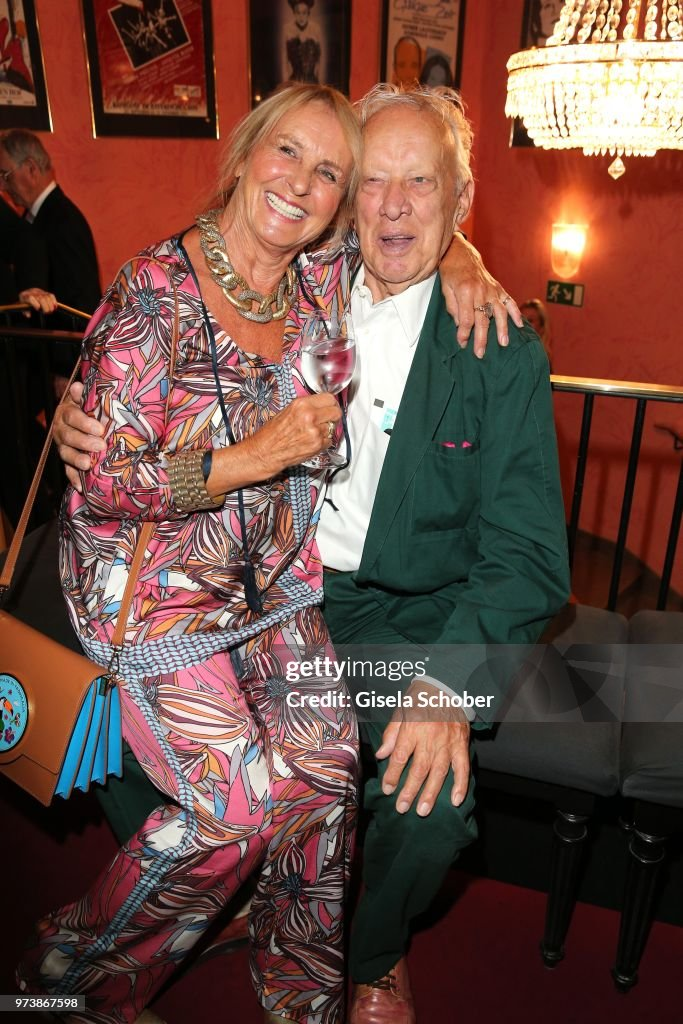What kind of stories might the couple share about the images in the background? The couple likely has a treasure trove of stories tied to the images in the background. They might reminisce about the first time they saw the play depicted in the nearest poster, recalling the laughter or the tears it brought them. Perhaps the chandelier reminds them of a grand gala they attended in their youth, filled with dancing and late-night conversations. The images might spark memories of friends they've made through their shared love of the arts, and the moments that defined their journey together. Each poster and artwork could lead to tales of evenings spent in theaters, galleries, and cultural events that are the backdrop of their enduring relationship. Imagine a fantastical story inspired by their appearance. Be very creative! In an enchanted realm where art and magic intertwine, the couple were once renowned as the guardians of the Crystal Chandelier, a mystical artifact that bestowed creativity upon the land. The woman, with her vibrant dress woven from enchanted flowers, could sing melodies that brought paintings to life. The man, in his ever-changing emerald suit, had the power to weave stories that transformed into breathtaking theater performances. Together, they protected and nurtured the creative spirit of their world, ensuring that imagination thrived. Now, at this grand gala, they’re witnessing the next generation of artists and storytellers, knowing their legacy of magic and wonder continues to inspire. 